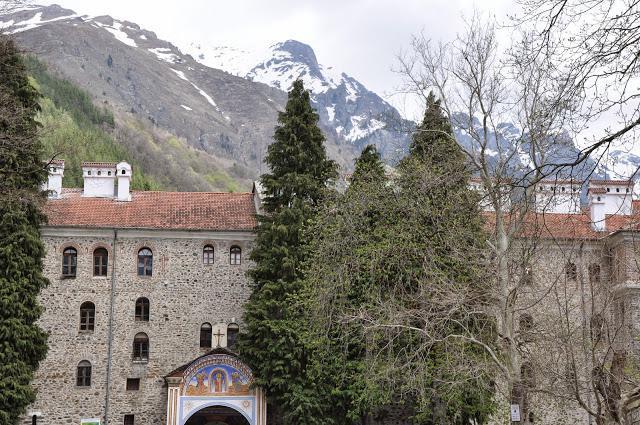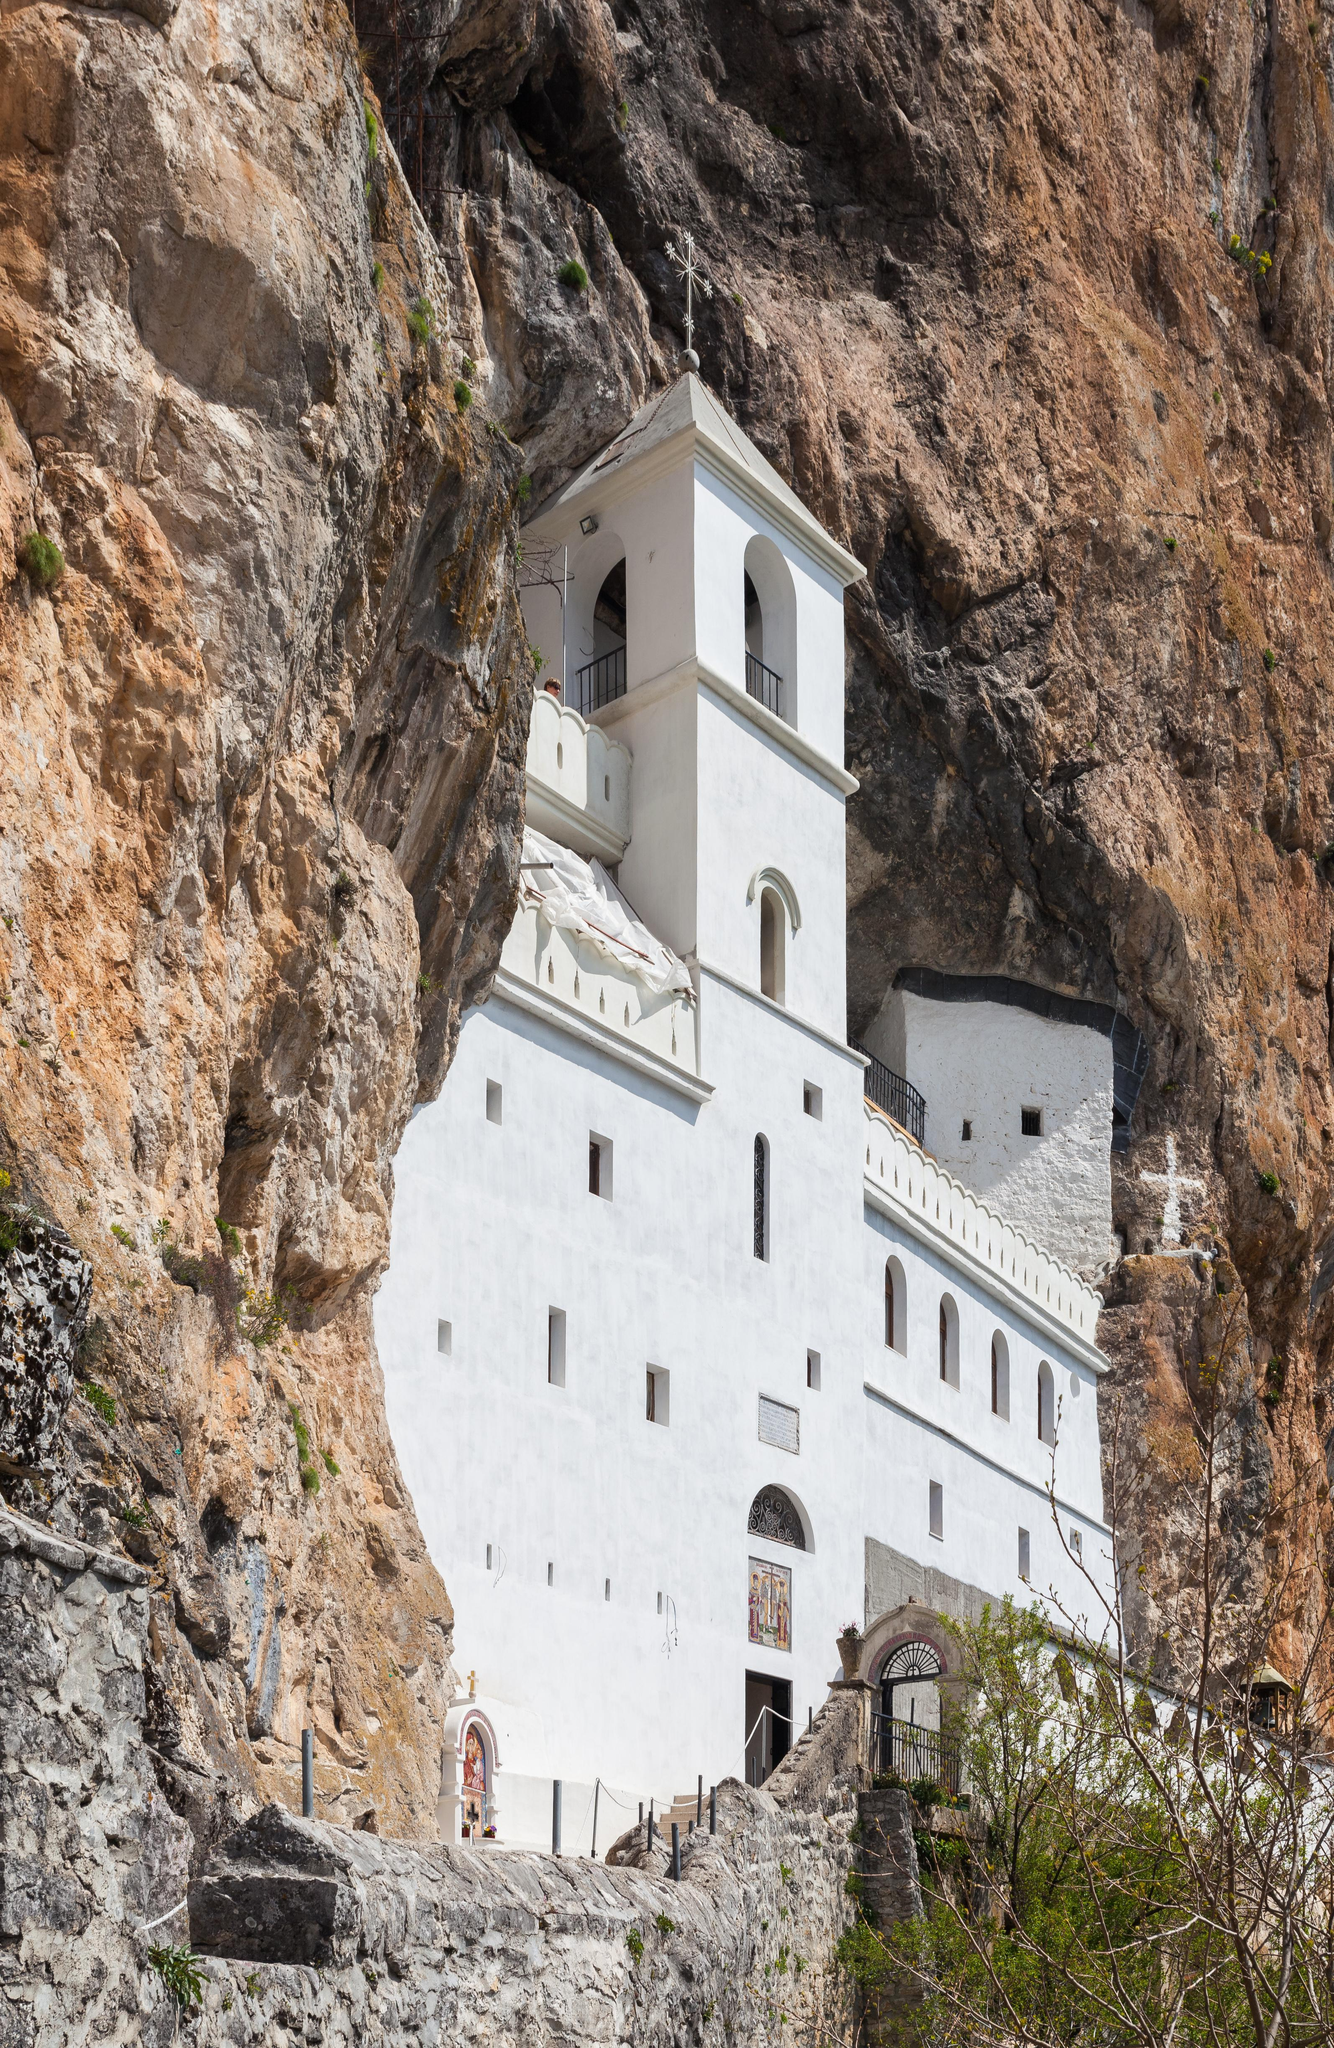The first image is the image on the left, the second image is the image on the right. For the images shown, is this caption "The structure in the image on the right appears to have been hewn from the mountain." true? Answer yes or no. Yes. 